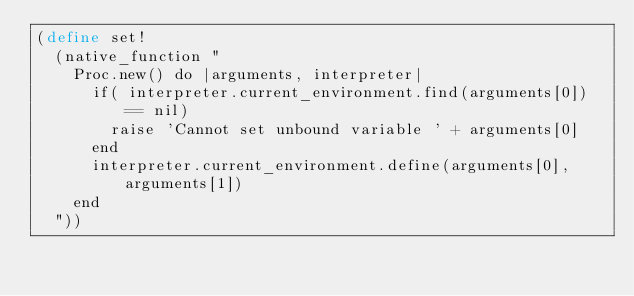<code> <loc_0><loc_0><loc_500><loc_500><_Scheme_>(define set!
  (native_function "
    Proc.new() do |arguments, interpreter|
      if( interpreter.current_environment.find(arguments[0]) == nil)
        raise 'Cannot set unbound variable ' + arguments[0]
      end
      interpreter.current_environment.define(arguments[0], arguments[1])
    end
  "))</code> 